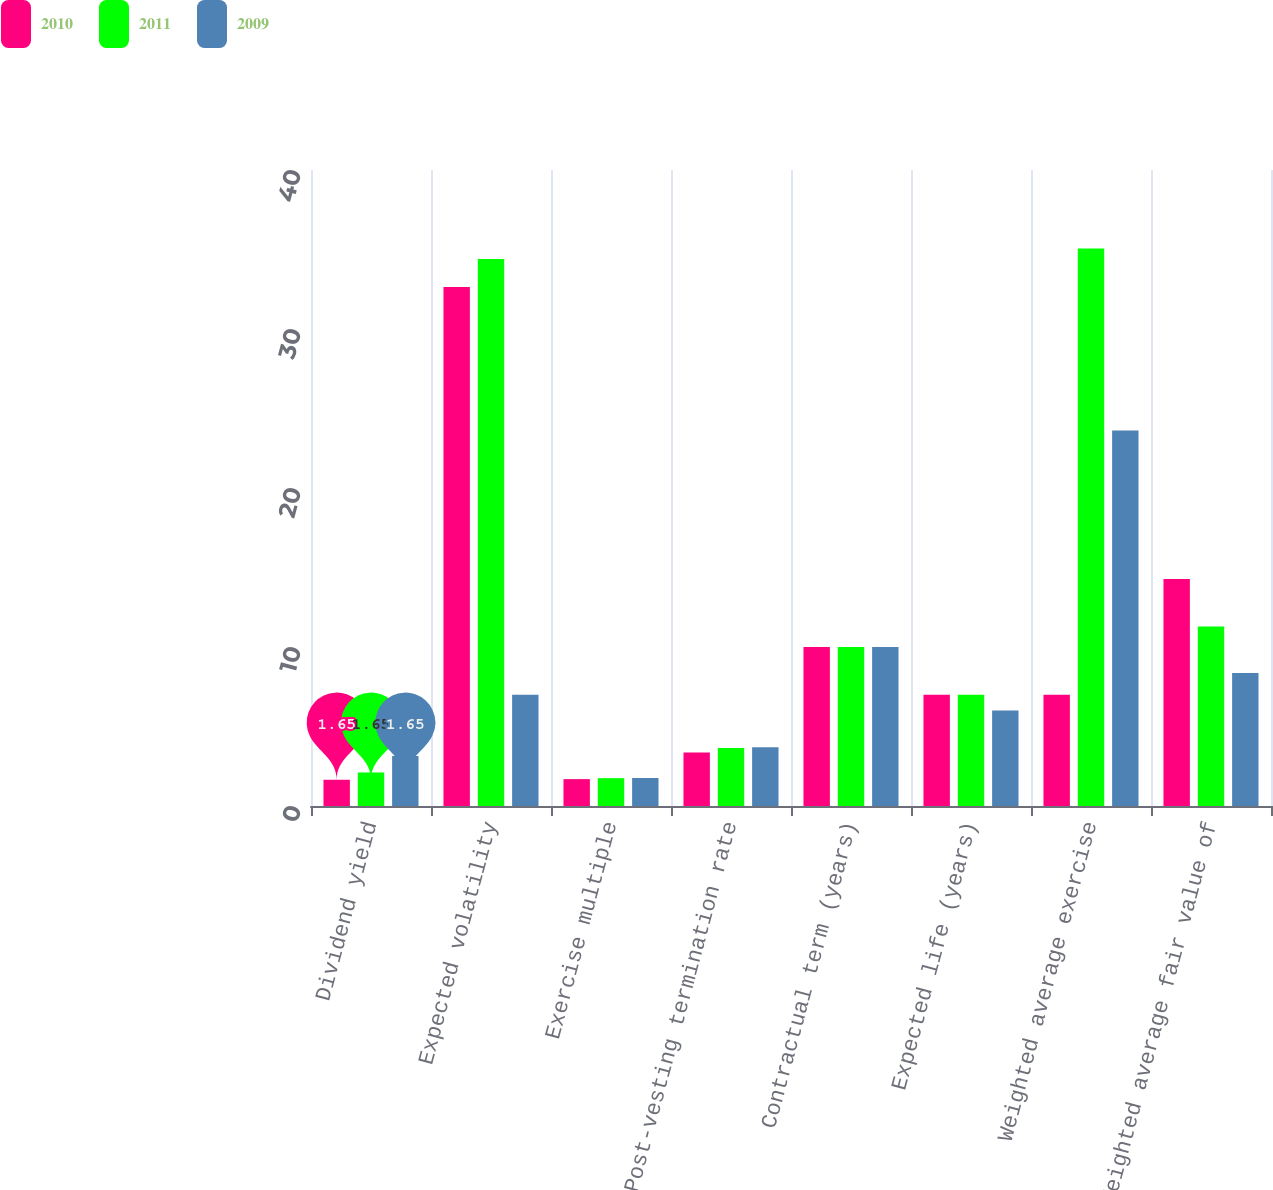Convert chart to OTSL. <chart><loc_0><loc_0><loc_500><loc_500><stacked_bar_chart><ecel><fcel>Dividend yield<fcel>Expected volatility<fcel>Exercise multiple<fcel>Post-vesting termination rate<fcel>Contractual term (years)<fcel>Expected life (years)<fcel>Weighted average exercise<fcel>Weighted average fair value of<nl><fcel>2010<fcel>1.65<fcel>32.64<fcel>1.69<fcel>3.36<fcel>10<fcel>7<fcel>7<fcel>14.27<nl><fcel>2011<fcel>2.11<fcel>34.41<fcel>1.75<fcel>3.64<fcel>10<fcel>7<fcel>35.06<fcel>11.29<nl><fcel>2009<fcel>3.15<fcel>7<fcel>1.76<fcel>3.7<fcel>10<fcel>6<fcel>23.61<fcel>8.37<nl></chart> 